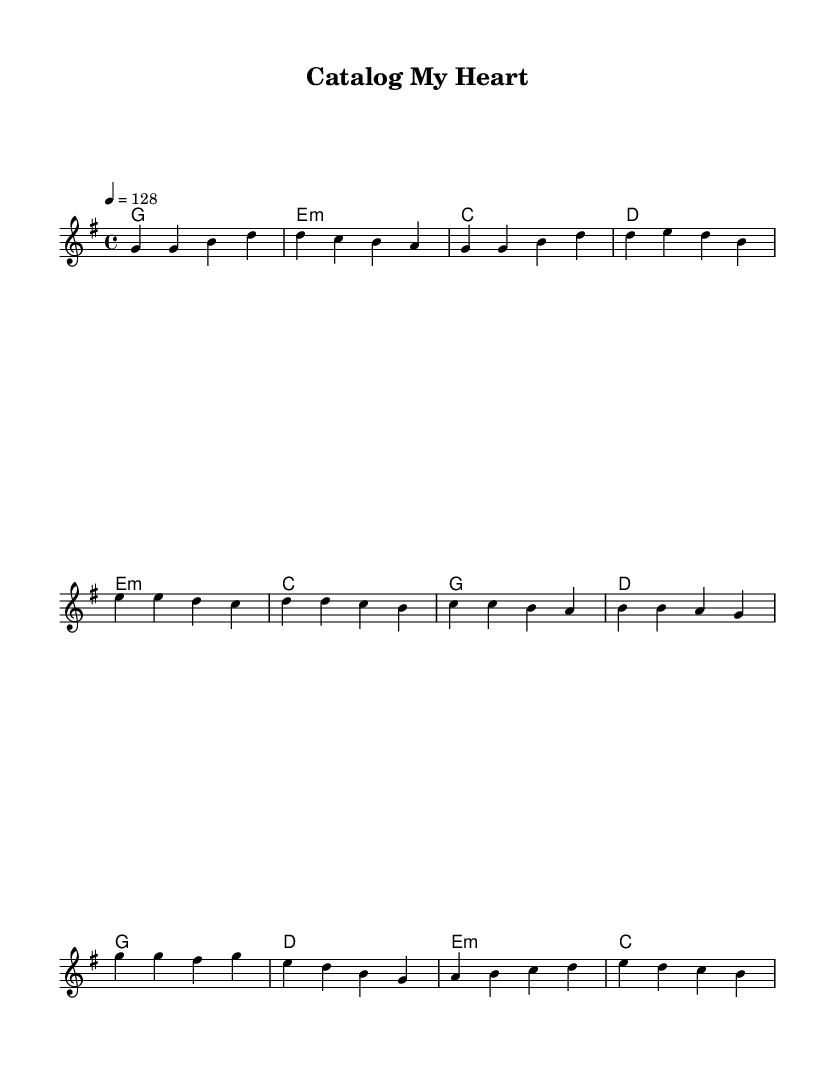What is the time signature of this music? The time signature indicates how many beats are in a measure and what note value gets one beat. In this case, it is written as 4/4, meaning there are four beats per measure and the quarter note gets one beat.
Answer: 4/4 What is the key signature of this music? The key signature appears at the beginning of the staff. It shows that the music is in G major, which has one sharp (F sharp), but it is not displayed in the sheet music notes. Thus, we conclude the key based on the context.
Answer: G major What is the tempo marking for this piece? The tempo marking is specified in the sheet music as "4 = 128," which refers to the metronome marking indicating the piece should be played at a speed of 128 beats per minute.
Answer: 128 How many measures are in the verse section? The verse section includes the initial four lines of melody which consist of eight measures in total, as counted from the bar lines.
Answer: 8 Which chord is played during the chorus? In the chorus segment of the music, the chords indicated include G major, D major, E minor, and C major, with G major being the first chord.
Answer: G major What themes are present in the lyrics? The lyrics denote themes around organizing emotions and cataloging feelings, showcasing a metaphorical approach to love as data. This thematic content is specifically tailored to match K-Pop's often emotive and playful lyrics.
Answer: Organizing emotions 